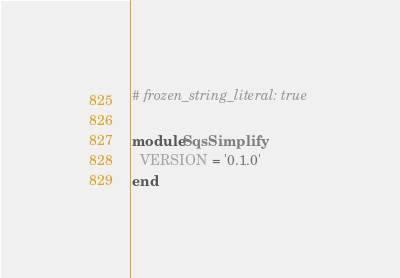<code> <loc_0><loc_0><loc_500><loc_500><_Ruby_># frozen_string_literal: true

module SqsSimplify
  VERSION = '0.1.0'
end
</code> 